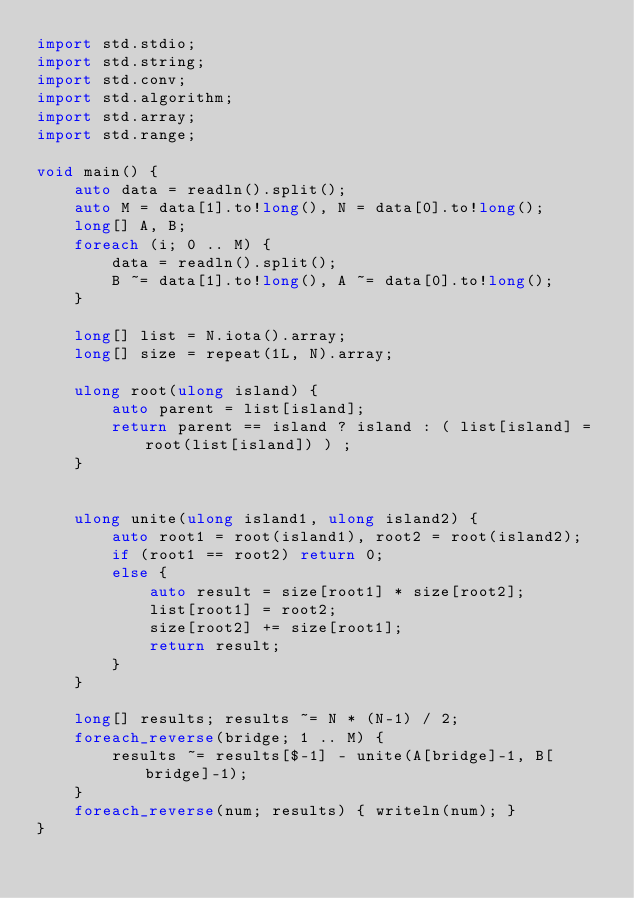<code> <loc_0><loc_0><loc_500><loc_500><_D_>import std.stdio;
import std.string;
import std.conv;
import std.algorithm;
import std.array;
import std.range;
 
void main() {
	auto data = readln().split();
	auto M = data[1].to!long(), N = data[0].to!long();
	long[] A, B;
	foreach (i; 0 .. M) {
		data = readln().split();
		B ~= data[1].to!long(), A ~= data[0].to!long();
	}
	
	long[] list = N.iota().array;
	long[] size = repeat(1L, N).array;
	
	ulong root(ulong island) {
		auto parent = list[island];
		return parent == island ? island : ( list[island] = root(list[island]) ) ;
	}
	
	
	ulong unite(ulong island1, ulong island2) {
		auto root1 = root(island1), root2 = root(island2);
		if (root1 == root2) return 0;
		else {
			auto result = size[root1] * size[root2];
			list[root1] = root2;
			size[root2] += size[root1];
			return result;
		}
	}
	
	long[] results; results ~= N * (N-1) / 2;
	foreach_reverse(bridge; 1 .. M) {
		results ~= results[$-1] - unite(A[bridge]-1, B[bridge]-1);
	}
	foreach_reverse(num; results) { writeln(num); }
}

</code> 